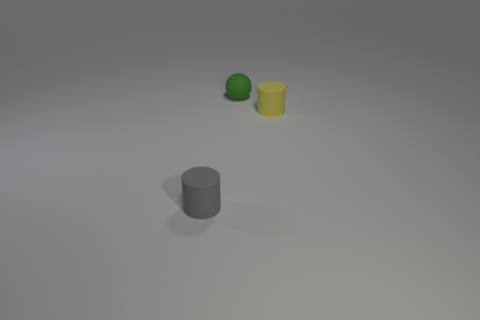What is the color of the tiny cylinder right of the tiny object to the left of the rubber sphere?
Give a very brief answer. Yellow. The yellow rubber object to the right of the small cylinder on the left side of the rubber object on the right side of the green sphere is what shape?
Give a very brief answer. Cylinder. What number of tiny cylinders are made of the same material as the gray thing?
Keep it short and to the point. 1. There is a tiny matte object to the right of the green sphere; what number of small things are left of it?
Keep it short and to the point. 2. What number of small green rubber things are there?
Ensure brevity in your answer.  1. Do the green ball and the small cylinder that is behind the small gray object have the same material?
Provide a short and direct response. Yes. What is the material of the tiny object that is both on the left side of the yellow rubber thing and right of the small gray matte cylinder?
Ensure brevity in your answer.  Rubber. How many other objects are there of the same color as the small rubber sphere?
Your answer should be compact. 0. Do the gray thing that is on the left side of the small yellow object and the matte thing on the right side of the green ball have the same size?
Keep it short and to the point. Yes. There is a small thing that is behind the small yellow cylinder; what is its color?
Your response must be concise. Green. 